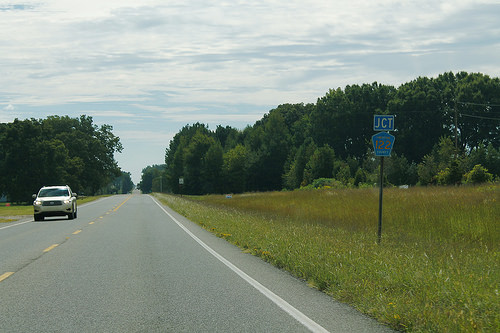<image>
Is the car behind the tree? No. The car is not behind the tree. From this viewpoint, the car appears to be positioned elsewhere in the scene. 